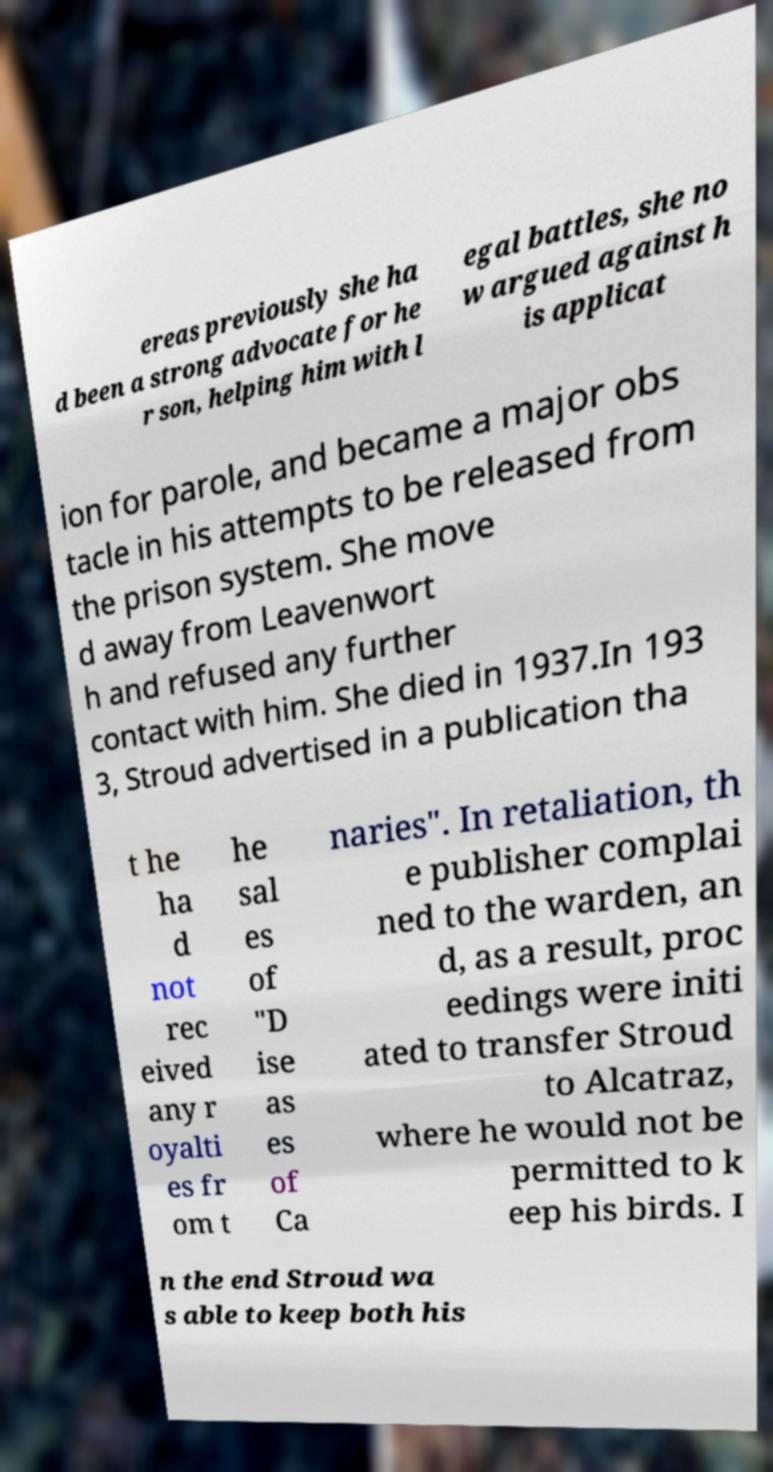Could you extract and type out the text from this image? ereas previously she ha d been a strong advocate for he r son, helping him with l egal battles, she no w argued against h is applicat ion for parole, and became a major obs tacle in his attempts to be released from the prison system. She move d away from Leavenwort h and refused any further contact with him. She died in 1937.In 193 3, Stroud advertised in a publication tha t he ha d not rec eived any r oyalti es fr om t he sal es of "D ise as es of Ca naries". In retaliation, th e publisher complai ned to the warden, an d, as a result, proc eedings were initi ated to transfer Stroud to Alcatraz, where he would not be permitted to k eep his birds. I n the end Stroud wa s able to keep both his 